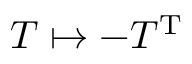<formula> <loc_0><loc_0><loc_500><loc_500>T \mapsto - T ^ { T }</formula> 